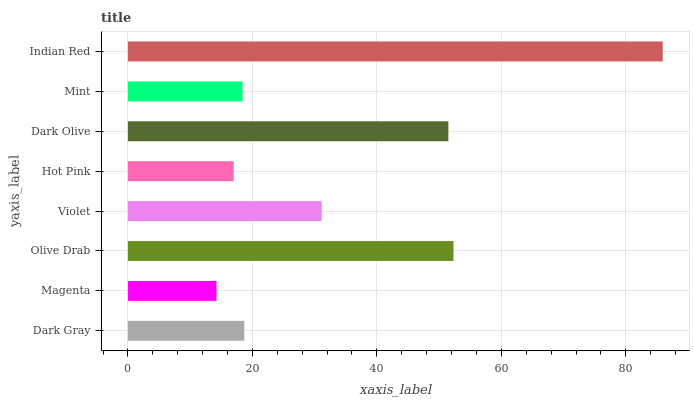Is Magenta the minimum?
Answer yes or no. Yes. Is Indian Red the maximum?
Answer yes or no. Yes. Is Olive Drab the minimum?
Answer yes or no. No. Is Olive Drab the maximum?
Answer yes or no. No. Is Olive Drab greater than Magenta?
Answer yes or no. Yes. Is Magenta less than Olive Drab?
Answer yes or no. Yes. Is Magenta greater than Olive Drab?
Answer yes or no. No. Is Olive Drab less than Magenta?
Answer yes or no. No. Is Violet the high median?
Answer yes or no. Yes. Is Dark Gray the low median?
Answer yes or no. Yes. Is Dark Olive the high median?
Answer yes or no. No. Is Dark Olive the low median?
Answer yes or no. No. 